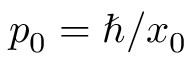Convert formula to latex. <formula><loc_0><loc_0><loc_500><loc_500>p _ { 0 } = \hbar { / } x _ { 0 }</formula> 